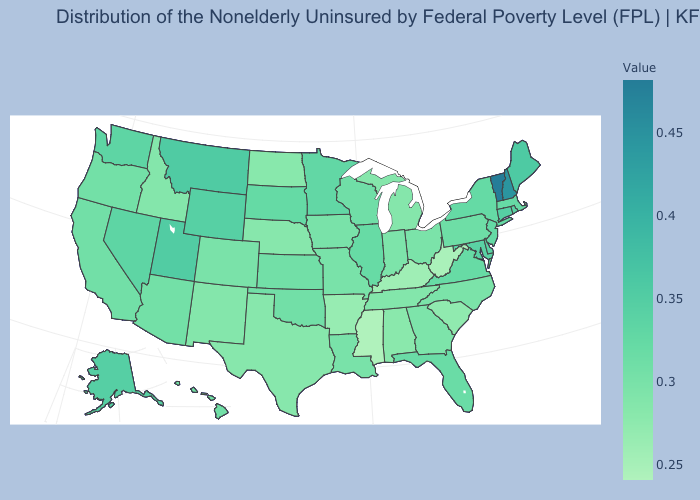Does South Dakota have a higher value than Texas?
Quick response, please. Yes. Does Minnesota have a higher value than Maine?
Answer briefly. No. Does Connecticut have the highest value in the Northeast?
Short answer required. No. Does Utah have a lower value than New Hampshire?
Be succinct. Yes. 